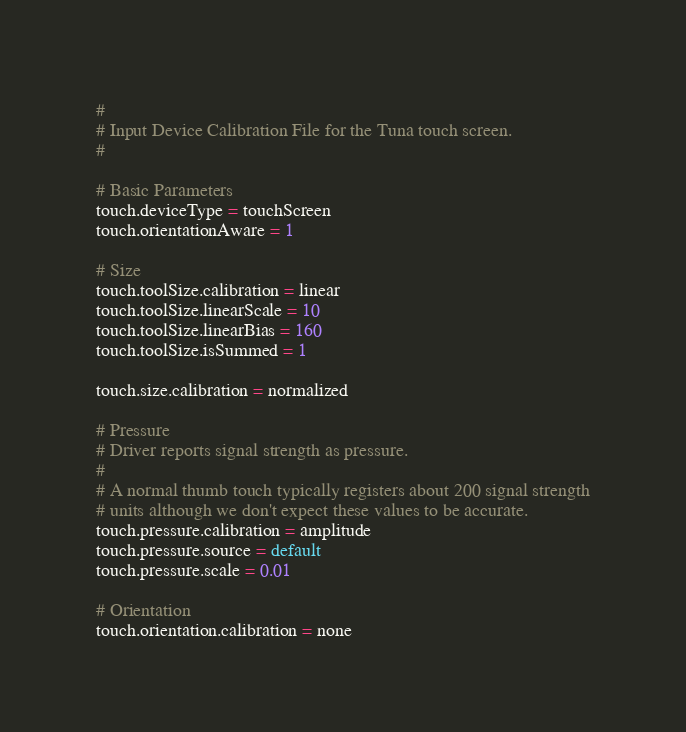<code> <loc_0><loc_0><loc_500><loc_500><_C_>#
# Input Device Calibration File for the Tuna touch screen.
#

# Basic Parameters
touch.deviceType = touchScreen
touch.orientationAware = 1

# Size
touch.toolSize.calibration = linear
touch.toolSize.linearScale = 10
touch.toolSize.linearBias = 160
touch.toolSize.isSummed = 1

touch.size.calibration = normalized

# Pressure
# Driver reports signal strength as pressure.
#
# A normal thumb touch typically registers about 200 signal strength
# units although we don't expect these values to be accurate.
touch.pressure.calibration = amplitude
touch.pressure.source = default
touch.pressure.scale = 0.01

# Orientation
touch.orientation.calibration = none

</code> 